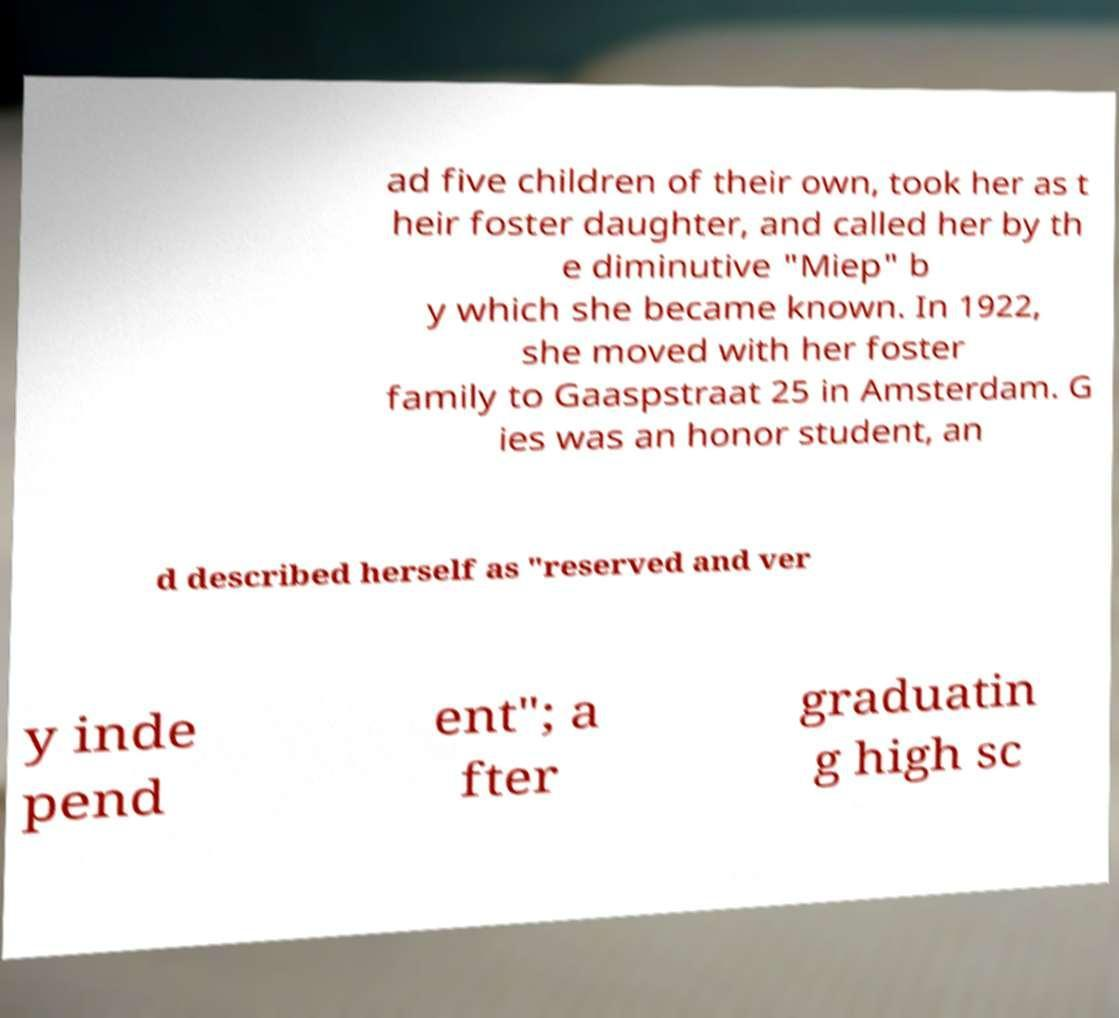Can you read and provide the text displayed in the image?This photo seems to have some interesting text. Can you extract and type it out for me? ad five children of their own, took her as t heir foster daughter, and called her by th e diminutive "Miep" b y which she became known. In 1922, she moved with her foster family to Gaaspstraat 25 in Amsterdam. G ies was an honor student, an d described herself as "reserved and ver y inde pend ent"; a fter graduatin g high sc 